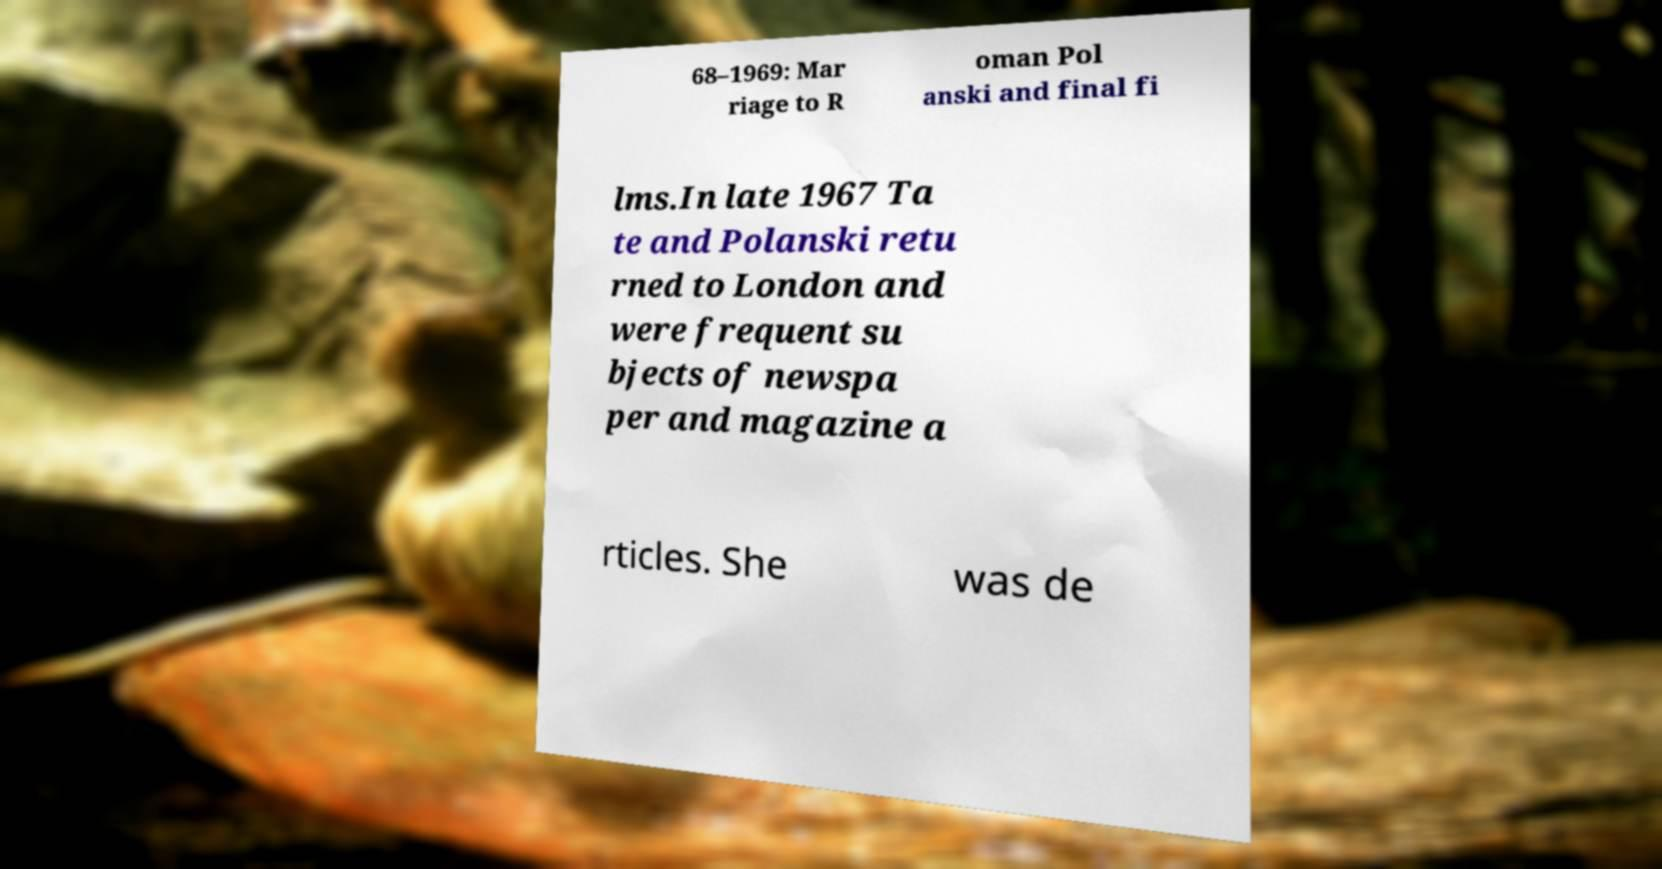Could you assist in decoding the text presented in this image and type it out clearly? 68–1969: Mar riage to R oman Pol anski and final fi lms.In late 1967 Ta te and Polanski retu rned to London and were frequent su bjects of newspa per and magazine a rticles. She was de 